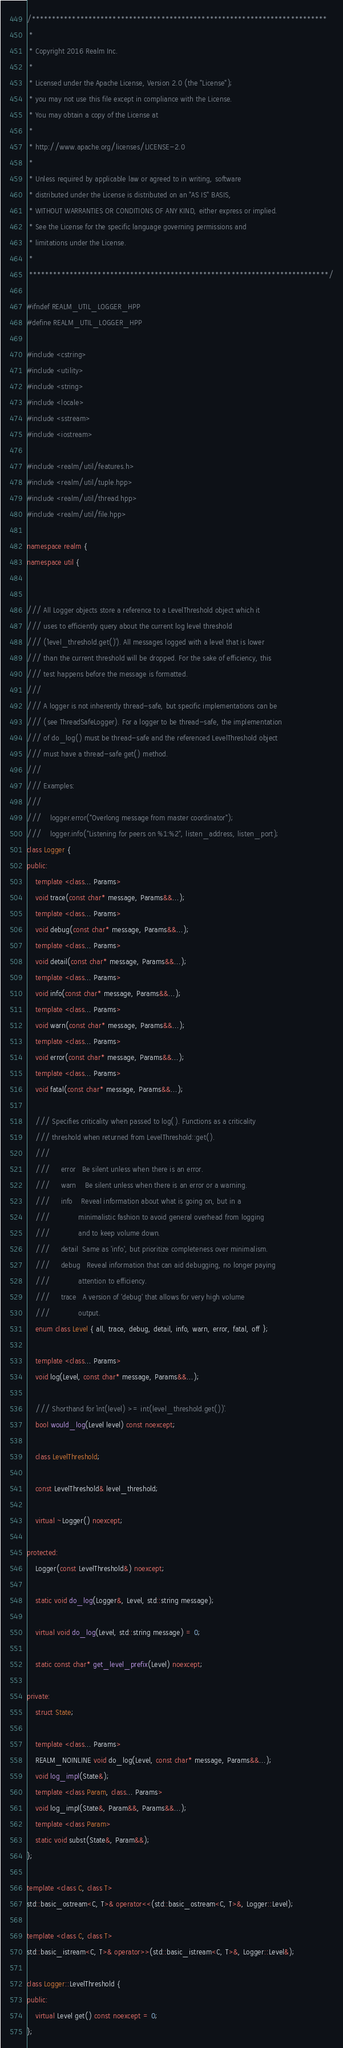Convert code to text. <code><loc_0><loc_0><loc_500><loc_500><_C++_>/*************************************************************************
 *
 * Copyright 2016 Realm Inc.
 *
 * Licensed under the Apache License, Version 2.0 (the "License");
 * you may not use this file except in compliance with the License.
 * You may obtain a copy of the License at
 *
 * http://www.apache.org/licenses/LICENSE-2.0
 *
 * Unless required by applicable law or agreed to in writing, software
 * distributed under the License is distributed on an "AS IS" BASIS,
 * WITHOUT WARRANTIES OR CONDITIONS OF ANY KIND, either express or implied.
 * See the License for the specific language governing permissions and
 * limitations under the License.
 *
 **************************************************************************/

#ifndef REALM_UTIL_LOGGER_HPP
#define REALM_UTIL_LOGGER_HPP

#include <cstring>
#include <utility>
#include <string>
#include <locale>
#include <sstream>
#include <iostream>

#include <realm/util/features.h>
#include <realm/util/tuple.hpp>
#include <realm/util/thread.hpp>
#include <realm/util/file.hpp>

namespace realm {
namespace util {


/// All Logger objects store a reference to a LevelThreshold object which it
/// uses to efficiently query about the current log level threshold
/// (`level_threshold.get()`). All messages logged with a level that is lower
/// than the current threshold will be dropped. For the sake of efficiency, this
/// test happens before the message is formatted.
///
/// A logger is not inherently thread-safe, but specific implementations can be
/// (see ThreadSafeLogger). For a logger to be thread-safe, the implementation
/// of do_log() must be thread-safe and the referenced LevelThreshold object
/// must have a thread-safe get() method.
///
/// Examples:
///
///    logger.error("Overlong message from master coordinator");
///    logger.info("Listening for peers on %1:%2", listen_address, listen_port);
class Logger {
public:
    template <class... Params>
    void trace(const char* message, Params&&...);
    template <class... Params>
    void debug(const char* message, Params&&...);
    template <class... Params>
    void detail(const char* message, Params&&...);
    template <class... Params>
    void info(const char* message, Params&&...);
    template <class... Params>
    void warn(const char* message, Params&&...);
    template <class... Params>
    void error(const char* message, Params&&...);
    template <class... Params>
    void fatal(const char* message, Params&&...);

    /// Specifies criticality when passed to log(). Functions as a criticality
    /// threshold when returned from LevelThreshold::get().
    ///
    ///     error   Be silent unless when there is an error.
    ///     warn    Be silent unless when there is an error or a warning.
    ///     info    Reveal information about what is going on, but in a
    ///             minimalistic fashion to avoid general overhead from logging
    ///             and to keep volume down.
    ///     detail  Same as 'info', but prioritize completeness over minimalism.
    ///     debug   Reveal information that can aid debugging, no longer paying
    ///             attention to efficiency.
    ///     trace   A version of 'debug' that allows for very high volume
    ///             output.
    enum class Level { all, trace, debug, detail, info, warn, error, fatal, off };

    template <class... Params>
    void log(Level, const char* message, Params&&...);

    /// Shorthand for `int(level) >= int(level_threshold.get())`.
    bool would_log(Level level) const noexcept;

    class LevelThreshold;

    const LevelThreshold& level_threshold;

    virtual ~Logger() noexcept;

protected:
    Logger(const LevelThreshold&) noexcept;

    static void do_log(Logger&, Level, std::string message);

    virtual void do_log(Level, std::string message) = 0;

    static const char* get_level_prefix(Level) noexcept;

private:
    struct State;

    template <class... Params>
    REALM_NOINLINE void do_log(Level, const char* message, Params&&...);
    void log_impl(State&);
    template <class Param, class... Params>
    void log_impl(State&, Param&&, Params&&...);
    template <class Param>
    static void subst(State&, Param&&);
};

template <class C, class T>
std::basic_ostream<C, T>& operator<<(std::basic_ostream<C, T>&, Logger::Level);

template <class C, class T>
std::basic_istream<C, T>& operator>>(std::basic_istream<C, T>&, Logger::Level&);

class Logger::LevelThreshold {
public:
    virtual Level get() const noexcept = 0;
};

</code> 